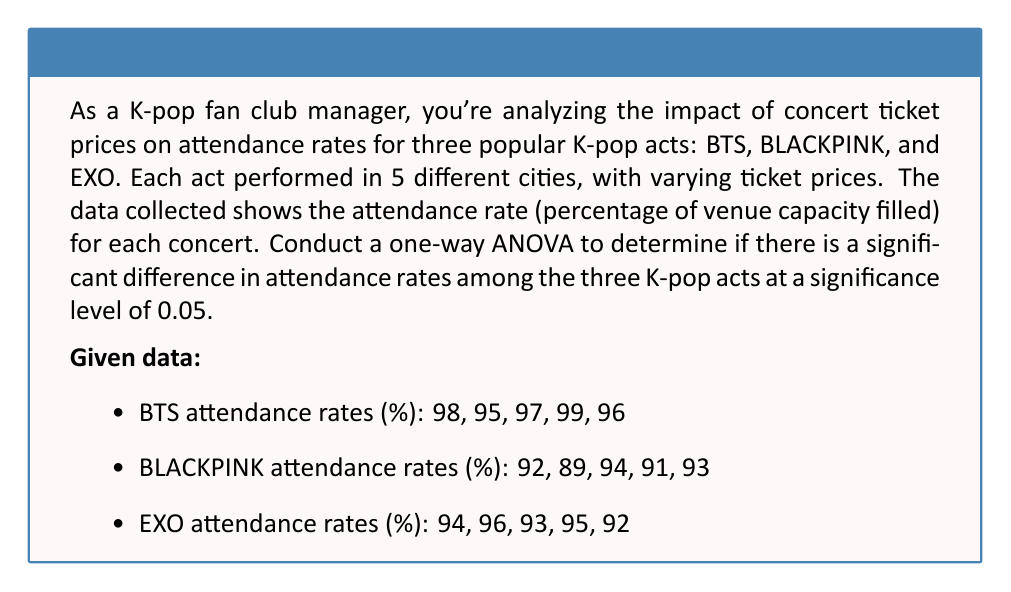Help me with this question. To conduct a one-way ANOVA, we'll follow these steps:

1. Calculate the sum of squares between groups (SSB), within groups (SSW), and total (SST).
2. Calculate the degrees of freedom for between groups (dfB), within groups (dfW), and total (dfT).
3. Calculate the mean squares for between groups (MSB) and within groups (MSW).
4. Calculate the F-statistic.
5. Compare the F-statistic to the critical F-value.

Step 1: Calculate sum of squares

First, we need to calculate the grand mean:
$\bar{X} = \frac{98 + 95 + 97 + 99 + 96 + 92 + 89 + 94 + 91 + 93 + 94 + 96 + 93 + 95 + 92}{15} = 94.27$

Now, we calculate the sum of squares:

SSB = $\sum_{i=1}^{k} n_i(\bar{X_i} - \bar{X})^2$
    = $5(97 - 94.27)^2 + 5(91.8 - 94.27)^2 + 5(94 - 94.27)^2$
    = $5(2.73)^2 + 5(-2.47)^2 + 5(-0.27)^2$
    = $37.2645 + 30.5045 + 0.3645 = 68.1335$

SSW = $\sum_{i=1}^{k} \sum_{j=1}^{n_i} (X_{ij} - \bar{X_i})^2$
    = $((98-97)^2 + (95-97)^2 + (97-97)^2 + (99-97)^2 + (96-97)^2)$
    + $((92-91.8)^2 + (89-91.8)^2 + (94-91.8)^2 + (91-91.8)^2 + (93-91.8)^2)$
    + $((94-94)^2 + (96-94)^2 + (93-94)^2 + (95-94)^2 + (92-94)^2)$
    = $10 + 18.8 + 10 = 38.8$

SST = SSB + SSW = $68.1335 + 38.8 = 106.9335$

Step 2: Calculate degrees of freedom

dfB = k - 1 = 3 - 1 = 2
dfW = N - k = 15 - 3 = 12
dfT = N - 1 = 15 - 1 = 14

Step 3: Calculate mean squares

MSB = SSB / dfB = $68.1335 / 2 = 34.06675$
MSW = SSW / dfW = $38.8 / 12 = 3.23333$

Step 4: Calculate F-statistic

F = MSB / MSW = $34.06675 / 3.23333 = 10.5361$

Step 5: Compare F-statistic to critical F-value

The critical F-value for $\alpha = 0.05$, dfB = 2, and dfW = 12 is approximately 3.89.

Since our calculated F-statistic (10.5361) is greater than the critical F-value (3.89), we reject the null hypothesis.
Answer: The one-way ANOVA results show a significant difference in attendance rates among the three K-pop acts (F(2, 12) = 10.5361, p < 0.05). We reject the null hypothesis and conclude that there is a statistically significant difference in attendance rates between BTS, BLACKPINK, and EXO. 